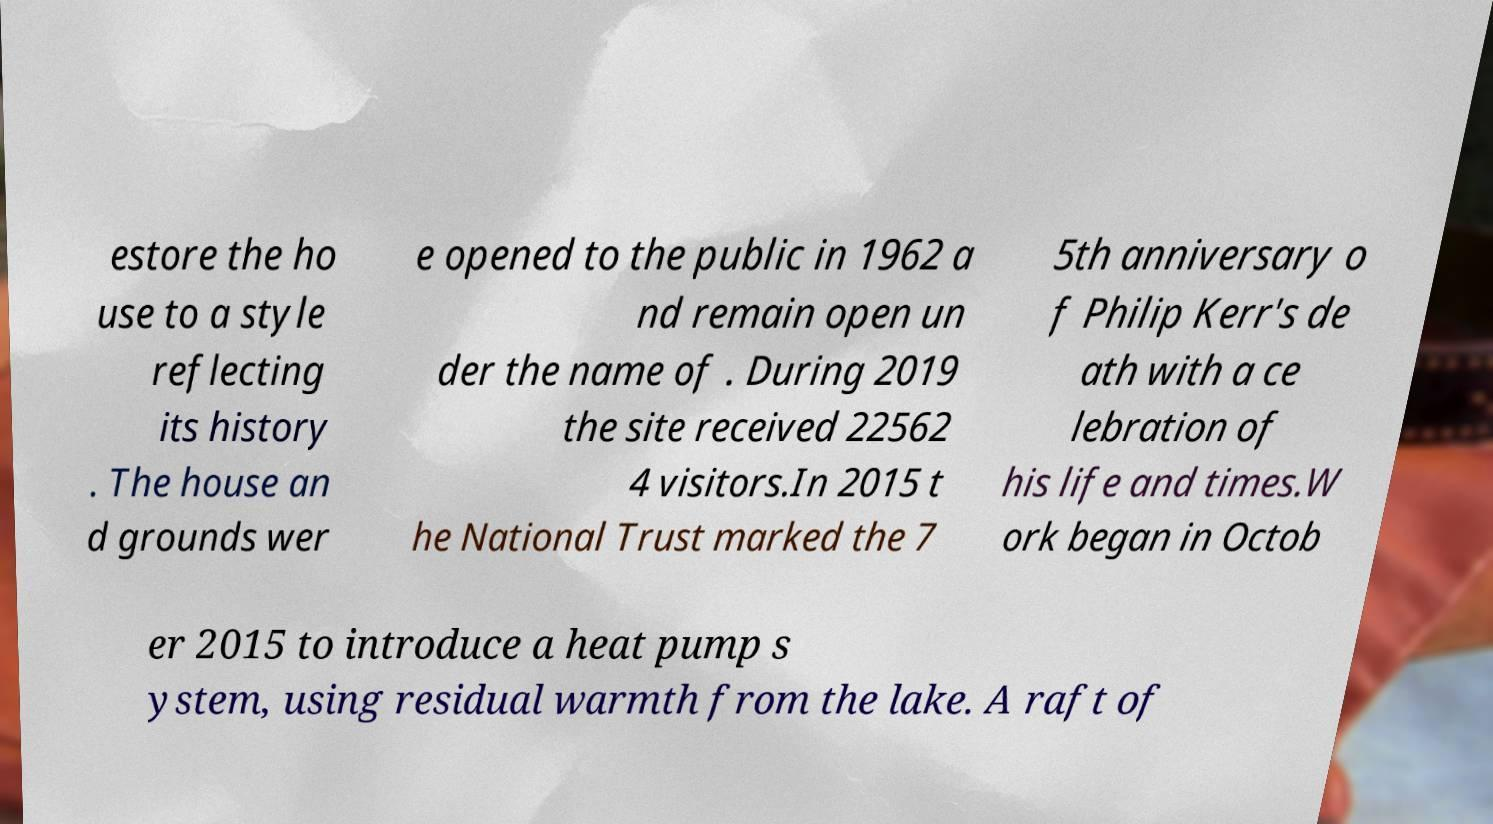I need the written content from this picture converted into text. Can you do that? estore the ho use to a style reflecting its history . The house an d grounds wer e opened to the public in 1962 a nd remain open un der the name of . During 2019 the site received 22562 4 visitors.In 2015 t he National Trust marked the 7 5th anniversary o f Philip Kerr's de ath with a ce lebration of his life and times.W ork began in Octob er 2015 to introduce a heat pump s ystem, using residual warmth from the lake. A raft of 